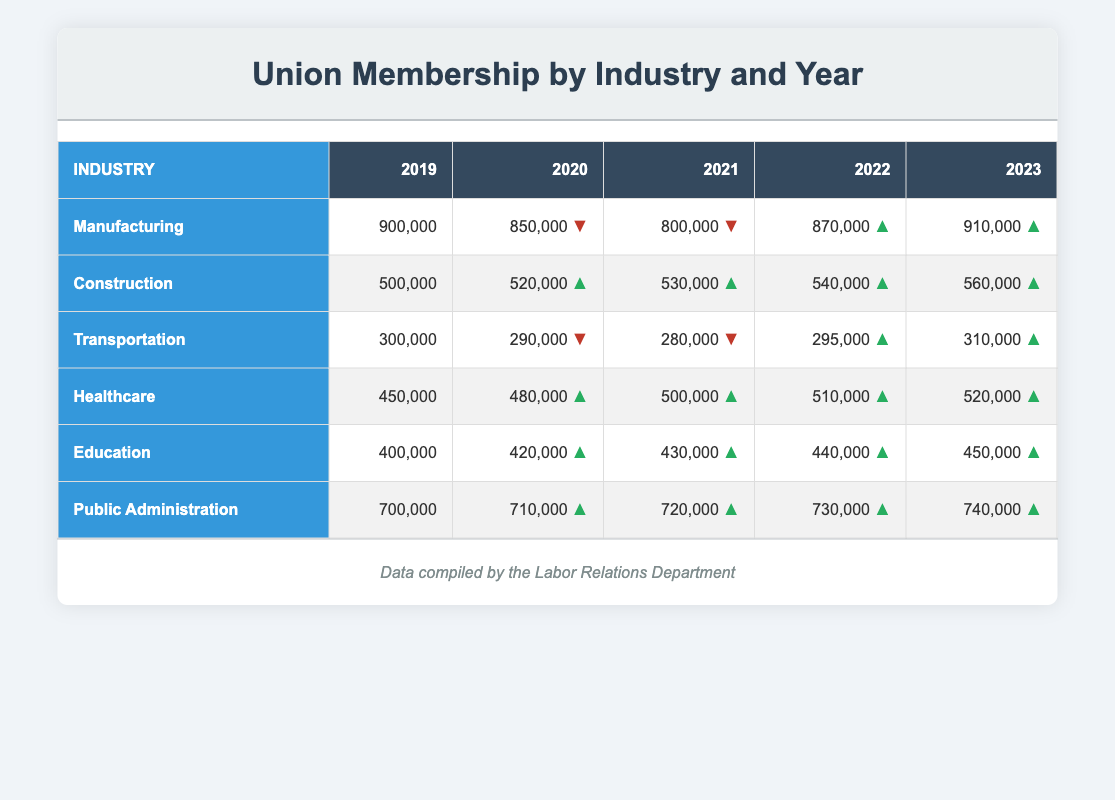What was the membership in the Healthcare industry in 2021? The Healthcare industry shows a membership of 500,000 in 2021 as per the data in the table.
Answer: 500,000 Which industry had the highest membership in 2023? In 2023, Public Administration had the highest membership with 740,000, as indicated in the last column of the table.
Answer: Public Administration What is the total union membership in the Construction industry from 2019 to 2023? The total for the Construction industry from 2019 to 2023 is calculated as follows: 500,000 + 520,000 + 530,000 + 540,000 + 560,000 = 2,650,000.
Answer: 2,650,000 Did the union membership in Manufacturing increase from 2022 to 2023? Yes, Manufacturing membership increased from 870,000 in 2022 to 910,000 in 2023, which shows a positive trend.
Answer: Yes By how much did Transportation membership decline from 2019 to 2021? Transportation membership decreased from 300,000 in 2019 to 280,000 in 2021. To find the decline: 300,000 - 280,000 = 20,000.
Answer: 20,000 Which industry consistently showed an upward trend in union membership from 2019 to 2023? The industries showing a consistent upward trend from 2019 to 2023 are Construction, Healthcare, Education, and Public Administration. Each of these industries have increased each year according to the data.
Answer: Construction, Healthcare, Education, Public Administration What was the membership in the Transportation industry in 2020 and how does it compare to 2023? In 2020, the Transportation membership was 290,000 and it increased to 310,000 in 2023, an increase of 20,000.
Answer: Increased by 20,000 Calculate the average membership for the Education industry over the years shown. The average for Education from 2019 to 2023 is calculated: (400,000 + 420,000 + 430,000 + 440,000 + 450,000) / 5 = 428,000.
Answer: 428,000 Is the Healthcare industry membership higher in 2020 than the Transportation industry membership in the same year? Yes, in 2020, Healthcare had 480,000 and Transportation had 290,000, indicating that Healthcare's membership is indeed higher.
Answer: Yes 